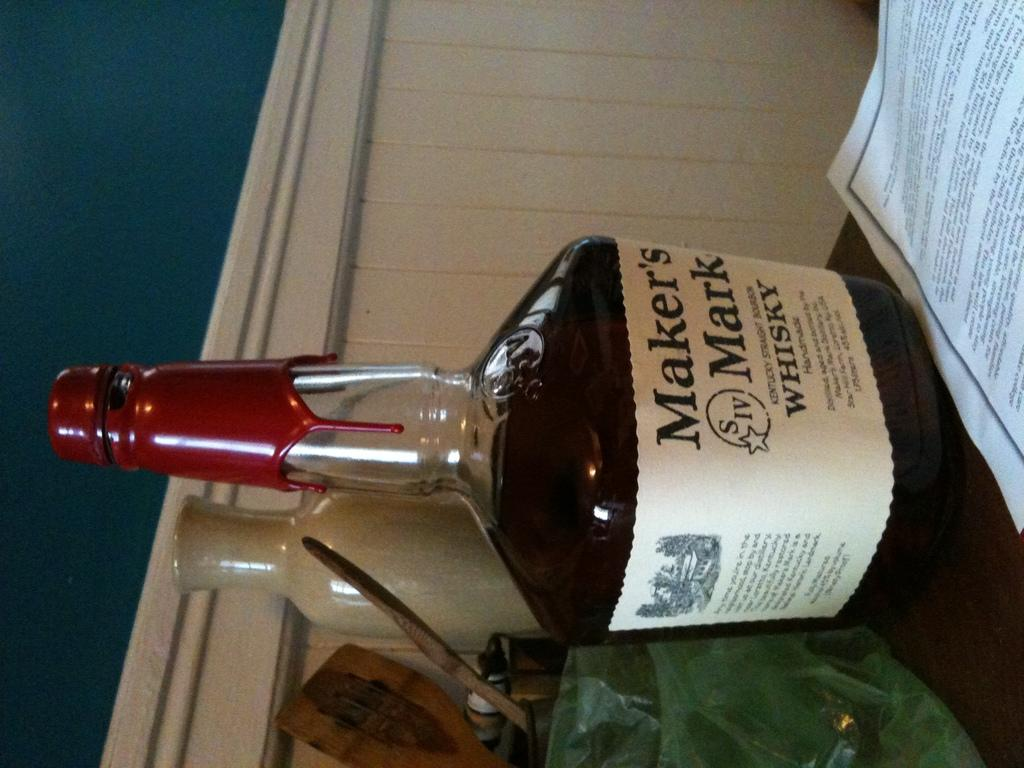<image>
Share a concise interpretation of the image provided. A bottle of Maker's Mark Whisky next to a piece of paper. 